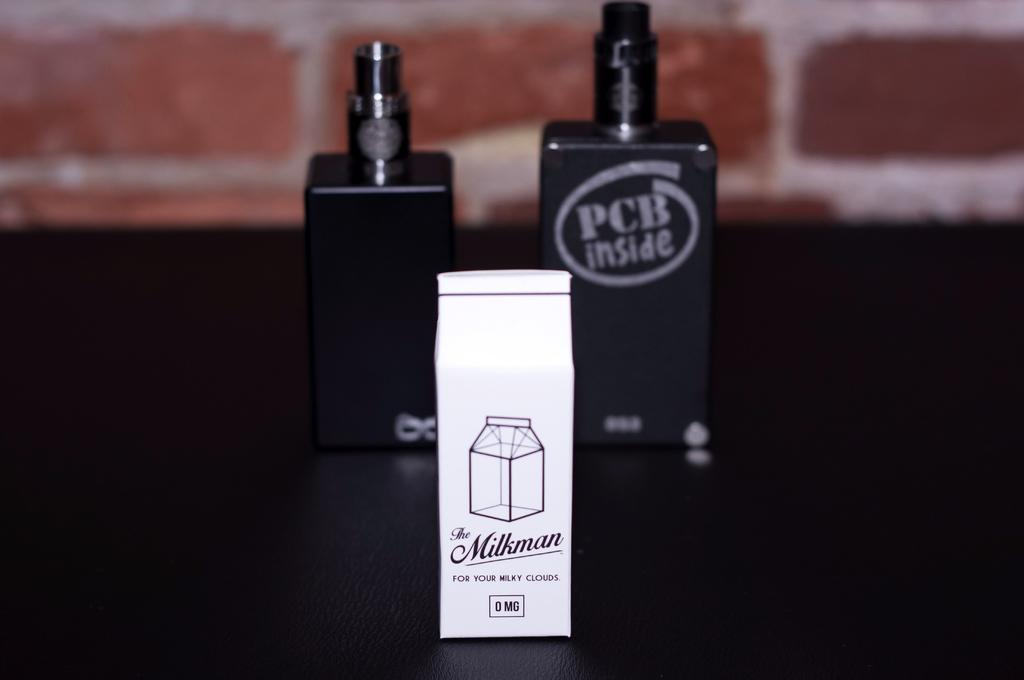<image>
Offer a succinct explanation of the picture presented. A white container says the Milkman for your milky clouds. 